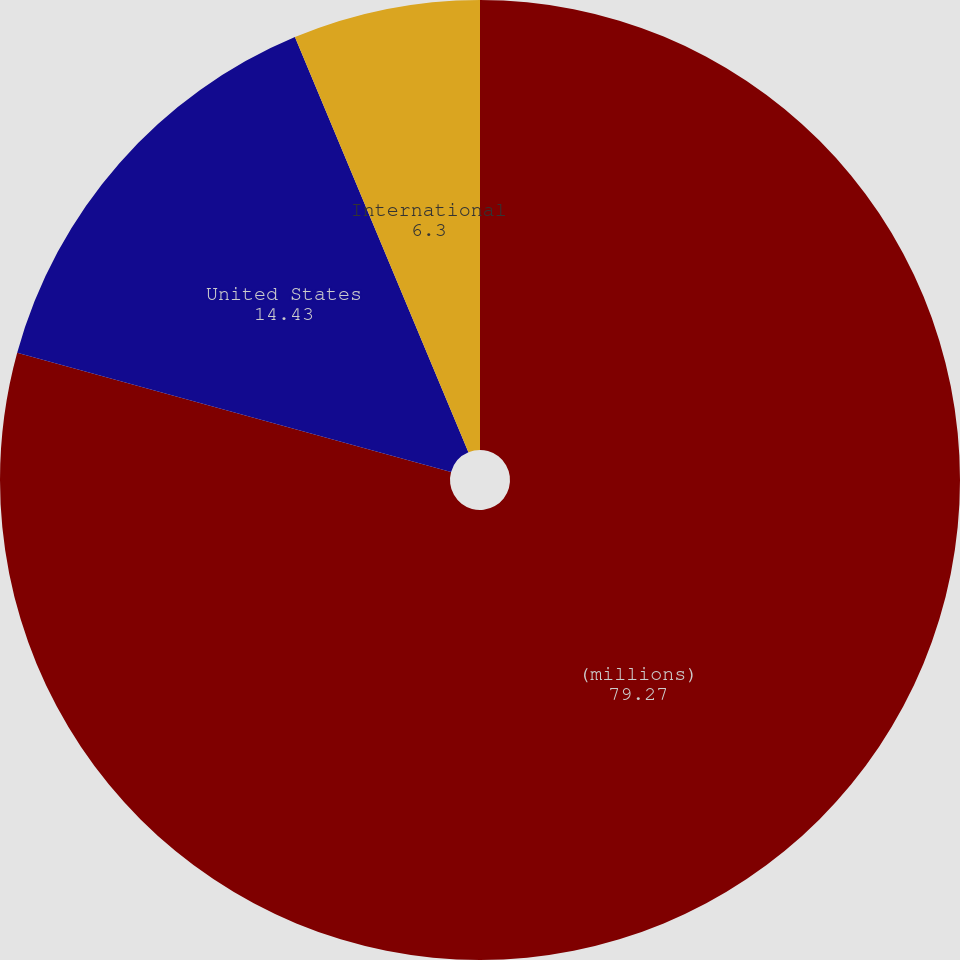Convert chart to OTSL. <chart><loc_0><loc_0><loc_500><loc_500><pie_chart><fcel>(millions)<fcel>United States<fcel>International<nl><fcel>79.27%<fcel>14.43%<fcel>6.3%<nl></chart> 